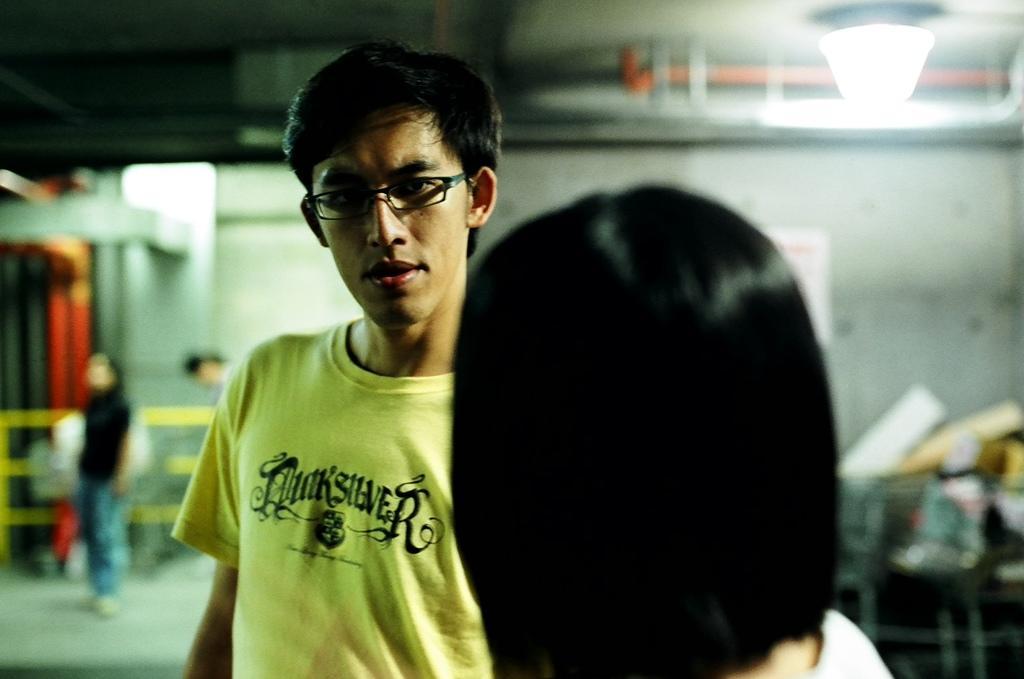Please provide a concise description of this image. This picture describes about group of people, in the middle of the image we can see a man, he wore spectacles, in the background we can see few lights, pipes and other things. 